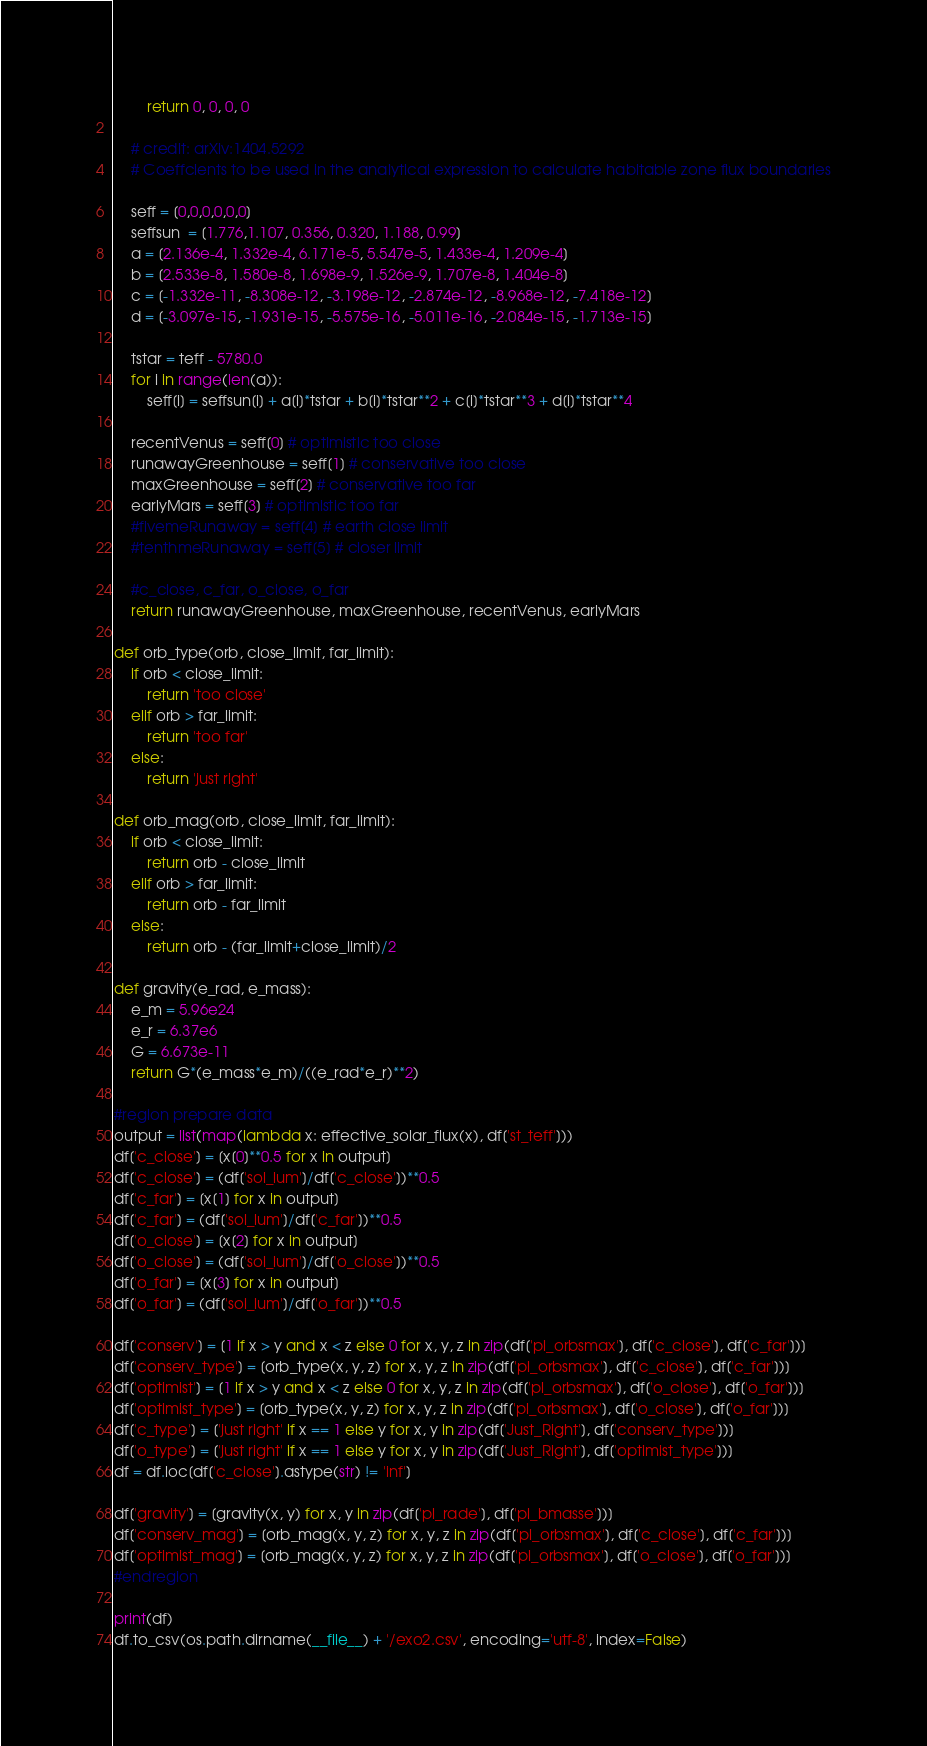Convert code to text. <code><loc_0><loc_0><loc_500><loc_500><_Python_>        return 0, 0, 0, 0

    # credit: arXiv:1404.5292
    # Coeffcients to be used in the analytical expression to calculate habitable zone flux boundaries

    seff = [0,0,0,0,0,0]
    seffsun  = [1.776,1.107, 0.356, 0.320, 1.188, 0.99] 
    a = [2.136e-4, 1.332e-4, 6.171e-5, 5.547e-5, 1.433e-4, 1.209e-4]
    b = [2.533e-8, 1.580e-8, 1.698e-9, 1.526e-9, 1.707e-8, 1.404e-8]
    c = [-1.332e-11, -8.308e-12, -3.198e-12, -2.874e-12, -8.968e-12, -7.418e-12]
    d = [-3.097e-15, -1.931e-15, -5.575e-16, -5.011e-16, -2.084e-15, -1.713e-15]

    tstar = teff - 5780.0
    for i in range(len(a)):
        seff[i] = seffsun[i] + a[i]*tstar + b[i]*tstar**2 + c[i]*tstar**3 + d[i]*tstar**4
    
    recentVenus = seff[0] # optimistic too close
    runawayGreenhouse = seff[1] # conservative too close
    maxGreenhouse = seff[2] # conservative too far
    earlyMars = seff[3] # optimistic too far
    #fivemeRunaway = seff[4] # earth close limit
    #tenthmeRunaway = seff[5] # closer limit 

    #c_close, c_far, o_close, o_far
    return runawayGreenhouse, maxGreenhouse, recentVenus, earlyMars

def orb_type(orb, close_limit, far_limit):
    if orb < close_limit:
        return 'too close'
    elif orb > far_limit:
        return 'too far'
    else:
        return 'just right'

def orb_mag(orb, close_limit, far_limit):
    if orb < close_limit:
        return orb - close_limit
    elif orb > far_limit:
        return orb - far_limit
    else:
        return orb - (far_limit+close_limit)/2

def gravity(e_rad, e_mass):
    e_m = 5.96e24
    e_r = 6.37e6
    G = 6.673e-11
    return G*(e_mass*e_m)/((e_rad*e_r)**2)

#region prepare data
output = list(map(lambda x: effective_solar_flux(x), df['st_teff']))
df['c_close'] = [x[0]**0.5 for x in output]
df['c_close'] = (df['sol_lum']/df['c_close'])**0.5
df['c_far'] = [x[1] for x in output]
df['c_far'] = (df['sol_lum']/df['c_far'])**0.5
df['o_close'] = [x[2] for x in output]
df['o_close'] = (df['sol_lum']/df['o_close'])**0.5
df['o_far'] = [x[3] for x in output]
df['o_far'] = (df['sol_lum']/df['o_far'])**0.5

df['conserv'] = [1 if x > y and x < z else 0 for x, y, z in zip(df['pl_orbsmax'], df['c_close'], df['c_far'])]
df['conserv_type'] = [orb_type(x, y, z) for x, y, z in zip(df['pl_orbsmax'], df['c_close'], df['c_far'])]
df['optimist'] = [1 if x > y and x < z else 0 for x, y, z in zip(df['pl_orbsmax'], df['o_close'], df['o_far'])]
df['optimist_type'] = [orb_type(x, y, z) for x, y, z in zip(df['pl_orbsmax'], df['o_close'], df['o_far'])]
df['c_type'] = ['just right' if x == 1 else y for x, y in zip(df['Just_Right'], df['conserv_type'])]
df['o_type'] = ['just right' if x == 1 else y for x, y in zip(df['Just_Right'], df['optimist_type'])]
df = df.loc[df['c_close'].astype(str) != 'inf']

df['gravity'] = [gravity(x, y) for x, y in zip(df['pl_rade'], df['pl_bmasse'])]
df['conserv_mag'] = [orb_mag(x, y, z) for x, y, z in zip(df['pl_orbsmax'], df['c_close'], df['c_far'])]
df['optimist_mag'] = [orb_mag(x, y, z) for x, y, z in zip(df['pl_orbsmax'], df['o_close'], df['o_far'])]
#endregion

print(df)
df.to_csv(os.path.dirname(__file__) + '/exo2.csv', encoding='utf-8', index=False)</code> 